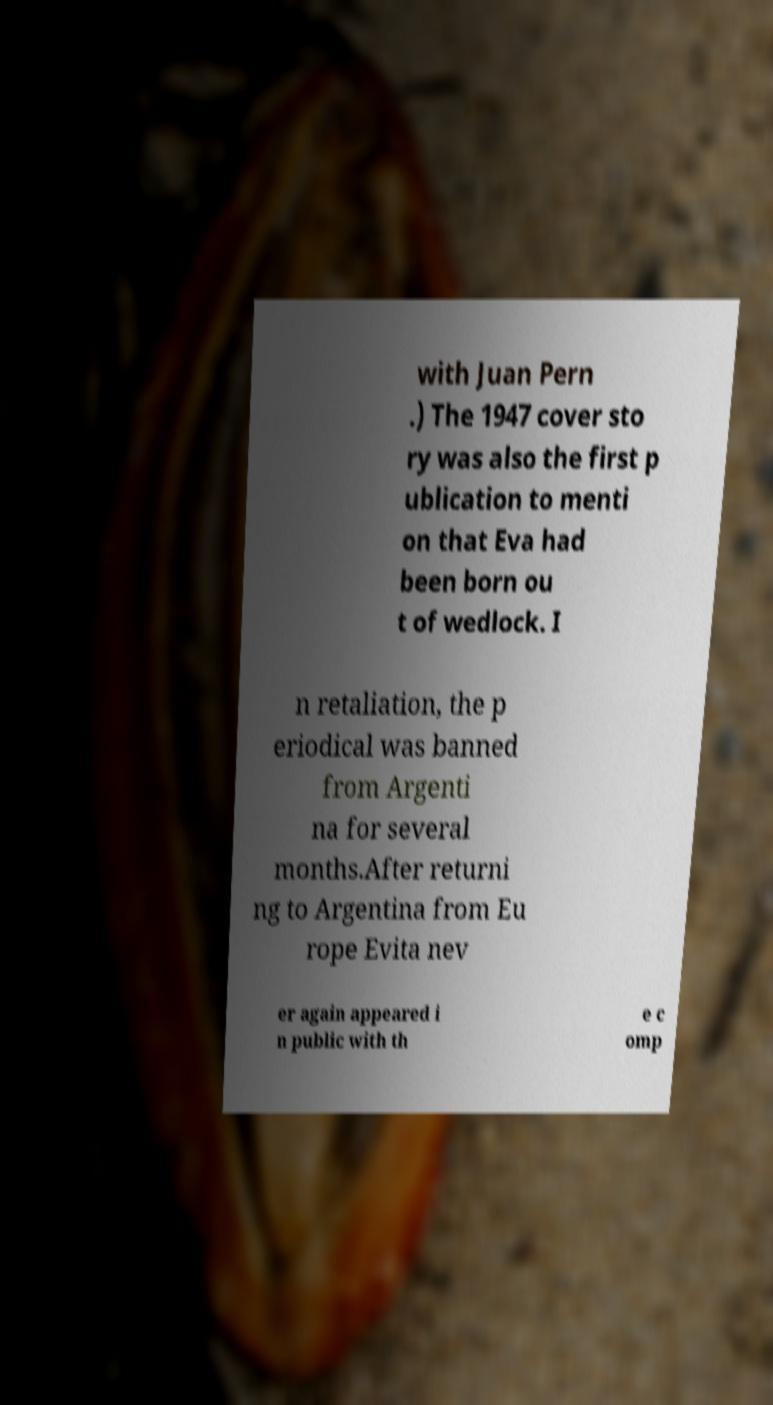For documentation purposes, I need the text within this image transcribed. Could you provide that? with Juan Pern .) The 1947 cover sto ry was also the first p ublication to menti on that Eva had been born ou t of wedlock. I n retaliation, the p eriodical was banned from Argenti na for several months.After returni ng to Argentina from Eu rope Evita nev er again appeared i n public with th e c omp 